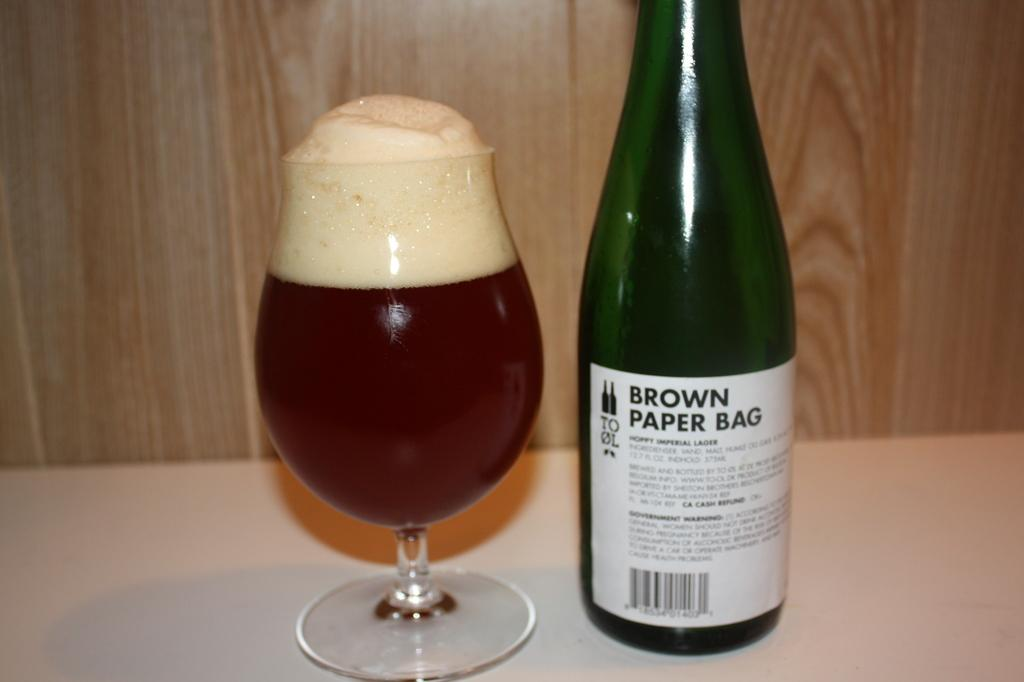What type of furniture is present in the image? There is a table in the image. What is placed on the table? There is a glass of wine and a wine bottle on the table. How long does the feast last in the image? There is no feast present in the image, so it is not possible to determine how long it might last. 